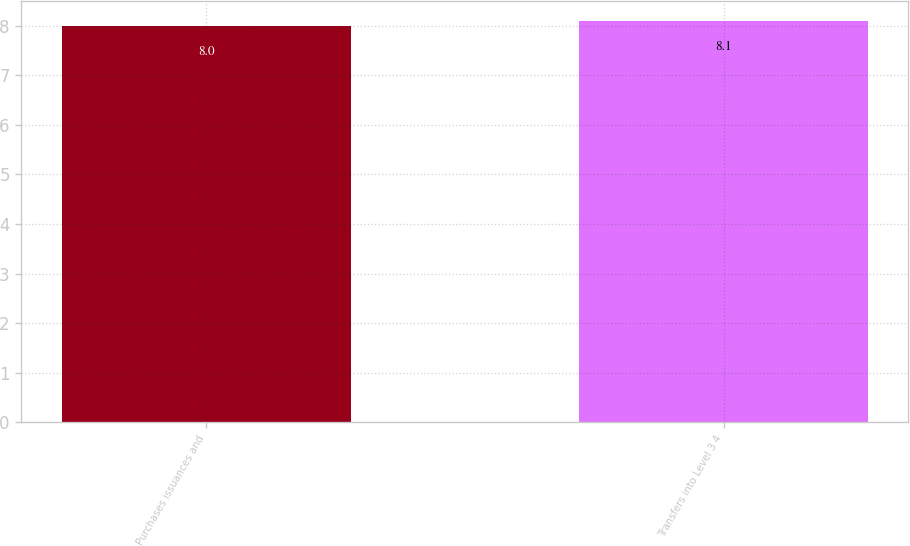Convert chart to OTSL. <chart><loc_0><loc_0><loc_500><loc_500><bar_chart><fcel>Purchases issuances and<fcel>Transfers into Level 3 4<nl><fcel>8<fcel>8.1<nl></chart> 